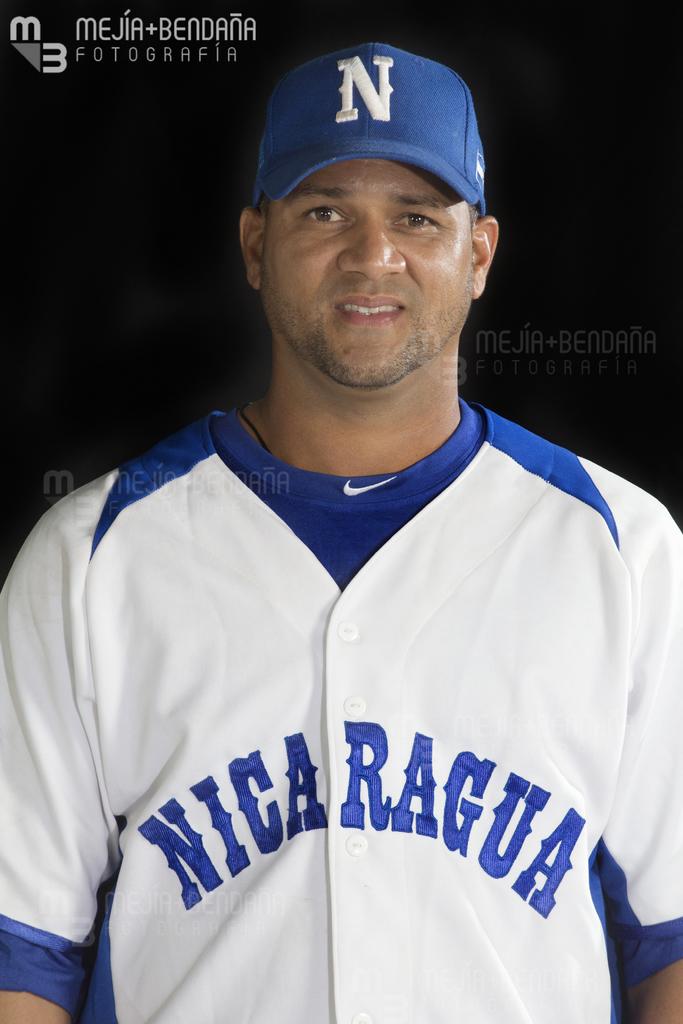What team does he play for?
Your answer should be compact. Nicaragua. What letter is on his hat?
Ensure brevity in your answer.  N. 